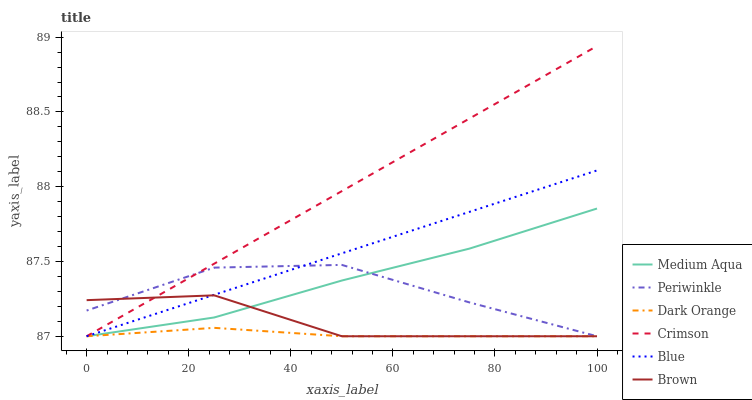Does Brown have the minimum area under the curve?
Answer yes or no. No. Does Brown have the maximum area under the curve?
Answer yes or no. No. Is Dark Orange the smoothest?
Answer yes or no. No. Is Dark Orange the roughest?
Answer yes or no. No. Does Brown have the highest value?
Answer yes or no. No. 